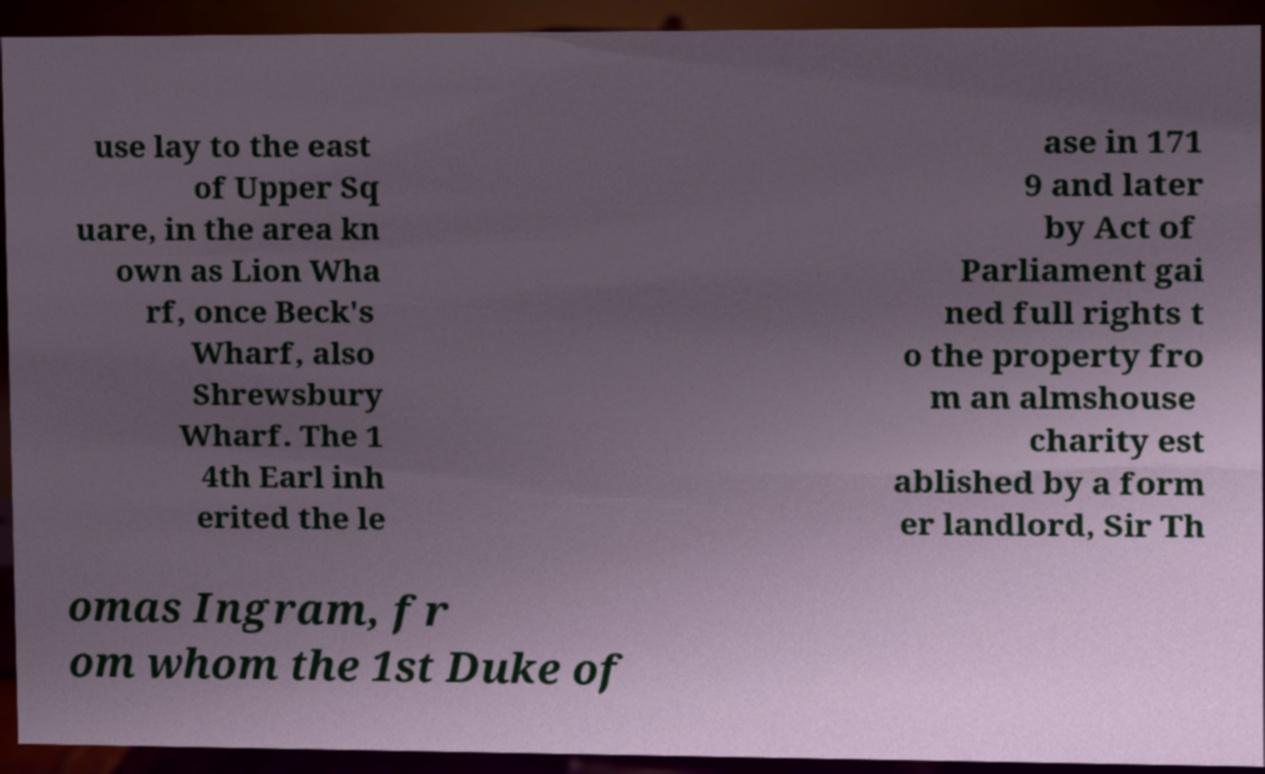Please read and relay the text visible in this image. What does it say? use lay to the east of Upper Sq uare, in the area kn own as Lion Wha rf, once Beck's Wharf, also Shrewsbury Wharf. The 1 4th Earl inh erited the le ase in 171 9 and later by Act of Parliament gai ned full rights t o the property fro m an almshouse charity est ablished by a form er landlord, Sir Th omas Ingram, fr om whom the 1st Duke of 